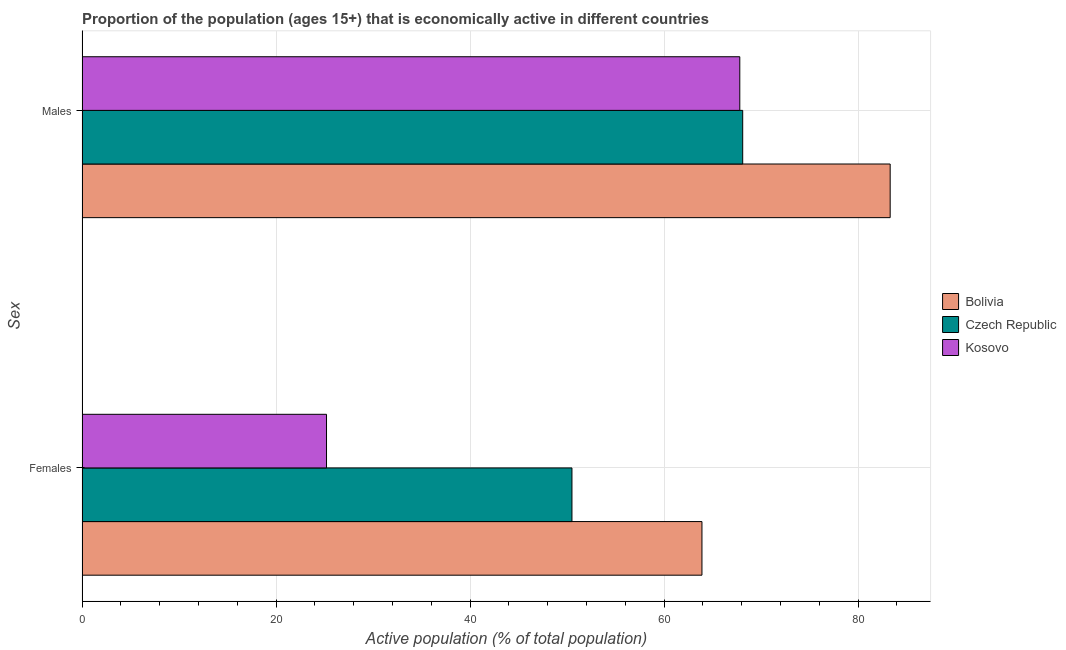Are the number of bars per tick equal to the number of legend labels?
Your answer should be compact. Yes. Are the number of bars on each tick of the Y-axis equal?
Provide a succinct answer. Yes. What is the label of the 2nd group of bars from the top?
Your answer should be very brief. Females. What is the percentage of economically active female population in Bolivia?
Your response must be concise. 63.9. Across all countries, what is the maximum percentage of economically active male population?
Your answer should be compact. 83.3. Across all countries, what is the minimum percentage of economically active female population?
Provide a short and direct response. 25.2. In which country was the percentage of economically active female population maximum?
Your answer should be compact. Bolivia. In which country was the percentage of economically active female population minimum?
Offer a very short reply. Kosovo. What is the total percentage of economically active female population in the graph?
Offer a terse response. 139.6. What is the difference between the percentage of economically active male population in Czech Republic and that in Bolivia?
Make the answer very short. -15.2. What is the difference between the percentage of economically active male population in Kosovo and the percentage of economically active female population in Bolivia?
Ensure brevity in your answer.  3.9. What is the average percentage of economically active female population per country?
Provide a succinct answer. 46.53. What is the difference between the percentage of economically active female population and percentage of economically active male population in Bolivia?
Provide a short and direct response. -19.4. In how many countries, is the percentage of economically active male population greater than 56 %?
Offer a terse response. 3. What is the ratio of the percentage of economically active male population in Bolivia to that in Czech Republic?
Your response must be concise. 1.22. In how many countries, is the percentage of economically active female population greater than the average percentage of economically active female population taken over all countries?
Offer a very short reply. 2. What does the 2nd bar from the top in Males represents?
Provide a short and direct response. Czech Republic. What does the 1st bar from the bottom in Males represents?
Ensure brevity in your answer.  Bolivia. How many bars are there?
Make the answer very short. 6. Are all the bars in the graph horizontal?
Your response must be concise. Yes. Does the graph contain grids?
Give a very brief answer. Yes. What is the title of the graph?
Provide a succinct answer. Proportion of the population (ages 15+) that is economically active in different countries. Does "New Zealand" appear as one of the legend labels in the graph?
Make the answer very short. No. What is the label or title of the X-axis?
Ensure brevity in your answer.  Active population (% of total population). What is the label or title of the Y-axis?
Provide a short and direct response. Sex. What is the Active population (% of total population) of Bolivia in Females?
Make the answer very short. 63.9. What is the Active population (% of total population) in Czech Republic in Females?
Offer a very short reply. 50.5. What is the Active population (% of total population) of Kosovo in Females?
Your response must be concise. 25.2. What is the Active population (% of total population) in Bolivia in Males?
Your answer should be very brief. 83.3. What is the Active population (% of total population) of Czech Republic in Males?
Your answer should be very brief. 68.1. What is the Active population (% of total population) in Kosovo in Males?
Give a very brief answer. 67.8. Across all Sex, what is the maximum Active population (% of total population) of Bolivia?
Ensure brevity in your answer.  83.3. Across all Sex, what is the maximum Active population (% of total population) in Czech Republic?
Offer a very short reply. 68.1. Across all Sex, what is the maximum Active population (% of total population) in Kosovo?
Give a very brief answer. 67.8. Across all Sex, what is the minimum Active population (% of total population) in Bolivia?
Your answer should be compact. 63.9. Across all Sex, what is the minimum Active population (% of total population) in Czech Republic?
Your response must be concise. 50.5. Across all Sex, what is the minimum Active population (% of total population) in Kosovo?
Your answer should be very brief. 25.2. What is the total Active population (% of total population) of Bolivia in the graph?
Your answer should be compact. 147.2. What is the total Active population (% of total population) in Czech Republic in the graph?
Offer a terse response. 118.6. What is the total Active population (% of total population) of Kosovo in the graph?
Make the answer very short. 93. What is the difference between the Active population (% of total population) of Bolivia in Females and that in Males?
Your response must be concise. -19.4. What is the difference between the Active population (% of total population) in Czech Republic in Females and that in Males?
Your answer should be compact. -17.6. What is the difference between the Active population (% of total population) of Kosovo in Females and that in Males?
Keep it short and to the point. -42.6. What is the difference between the Active population (% of total population) of Bolivia in Females and the Active population (% of total population) of Czech Republic in Males?
Your answer should be compact. -4.2. What is the difference between the Active population (% of total population) in Czech Republic in Females and the Active population (% of total population) in Kosovo in Males?
Your response must be concise. -17.3. What is the average Active population (% of total population) in Bolivia per Sex?
Give a very brief answer. 73.6. What is the average Active population (% of total population) in Czech Republic per Sex?
Keep it short and to the point. 59.3. What is the average Active population (% of total population) in Kosovo per Sex?
Offer a very short reply. 46.5. What is the difference between the Active population (% of total population) of Bolivia and Active population (% of total population) of Czech Republic in Females?
Ensure brevity in your answer.  13.4. What is the difference between the Active population (% of total population) of Bolivia and Active population (% of total population) of Kosovo in Females?
Offer a terse response. 38.7. What is the difference between the Active population (% of total population) in Czech Republic and Active population (% of total population) in Kosovo in Females?
Give a very brief answer. 25.3. What is the difference between the Active population (% of total population) in Bolivia and Active population (% of total population) in Kosovo in Males?
Offer a very short reply. 15.5. What is the difference between the Active population (% of total population) in Czech Republic and Active population (% of total population) in Kosovo in Males?
Make the answer very short. 0.3. What is the ratio of the Active population (% of total population) of Bolivia in Females to that in Males?
Provide a short and direct response. 0.77. What is the ratio of the Active population (% of total population) of Czech Republic in Females to that in Males?
Offer a terse response. 0.74. What is the ratio of the Active population (% of total population) in Kosovo in Females to that in Males?
Your answer should be very brief. 0.37. What is the difference between the highest and the second highest Active population (% of total population) of Bolivia?
Ensure brevity in your answer.  19.4. What is the difference between the highest and the second highest Active population (% of total population) of Czech Republic?
Keep it short and to the point. 17.6. What is the difference between the highest and the second highest Active population (% of total population) of Kosovo?
Your answer should be very brief. 42.6. What is the difference between the highest and the lowest Active population (% of total population) of Kosovo?
Provide a short and direct response. 42.6. 